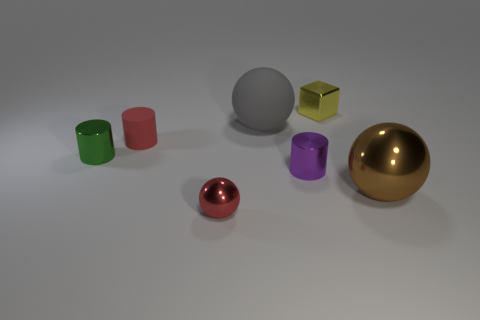There is a ball that is the same color as the matte cylinder; what is its material?
Keep it short and to the point. Metal. What is the shape of the red thing in front of the large thing in front of the purple thing?
Keep it short and to the point. Sphere. What number of brown things are the same material as the large brown ball?
Provide a succinct answer. 0. There is a tiny ball that is made of the same material as the green thing; what color is it?
Offer a terse response. Red. There is a red object that is behind the big object that is right of the shiny cylinder on the right side of the green metallic cylinder; what size is it?
Your response must be concise. Small. Are there fewer tiny red matte things than matte things?
Give a very brief answer. Yes. There is another rubber object that is the same shape as the small green thing; what is its color?
Your response must be concise. Red. There is a red object behind the big thing that is in front of the small green cylinder; is there a cylinder that is in front of it?
Make the answer very short. Yes. Do the green thing and the purple thing have the same shape?
Your answer should be compact. Yes. Is the number of big brown metallic spheres in front of the yellow thing less than the number of big yellow shiny cylinders?
Your answer should be compact. No. 